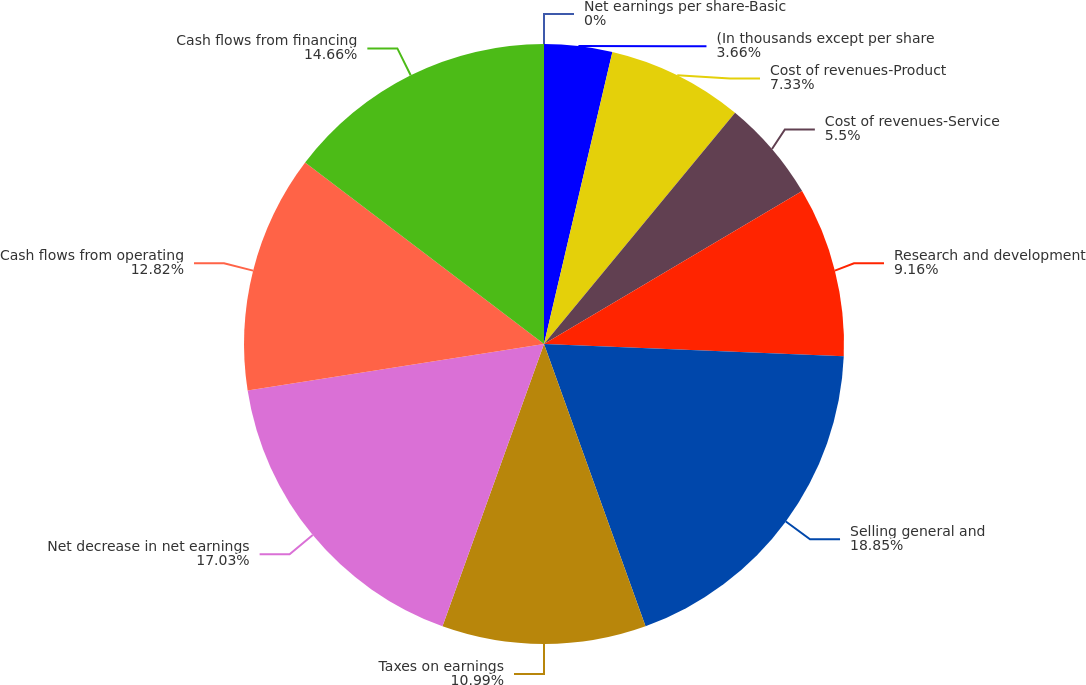Convert chart to OTSL. <chart><loc_0><loc_0><loc_500><loc_500><pie_chart><fcel>(In thousands except per share<fcel>Cost of revenues-Product<fcel>Cost of revenues-Service<fcel>Research and development<fcel>Selling general and<fcel>Taxes on earnings<fcel>Net decrease in net earnings<fcel>Cash flows from operating<fcel>Cash flows from financing<fcel>Net earnings per share-Basic<nl><fcel>3.66%<fcel>7.33%<fcel>5.5%<fcel>9.16%<fcel>18.86%<fcel>10.99%<fcel>17.03%<fcel>12.82%<fcel>14.66%<fcel>0.0%<nl></chart> 